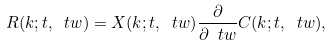<formula> <loc_0><loc_0><loc_500><loc_500>R ( k ; t , \ t w ) = X ( k ; t , \ t w ) \frac { \partial } { \partial \ t w } C ( k ; t , \ t w ) ,</formula> 